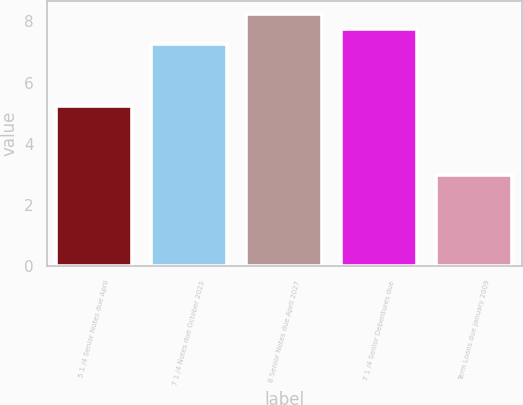Convert chart. <chart><loc_0><loc_0><loc_500><loc_500><bar_chart><fcel>5 1 /4 Senior Notes due April<fcel>7 1 /4 Notes due October 2023<fcel>8 Senior Notes due April 2027<fcel>7 1 /4 Senior Debentures due<fcel>Term Loans due January 2009<nl><fcel>5.25<fcel>7.25<fcel>8.25<fcel>7.75<fcel>3<nl></chart> 